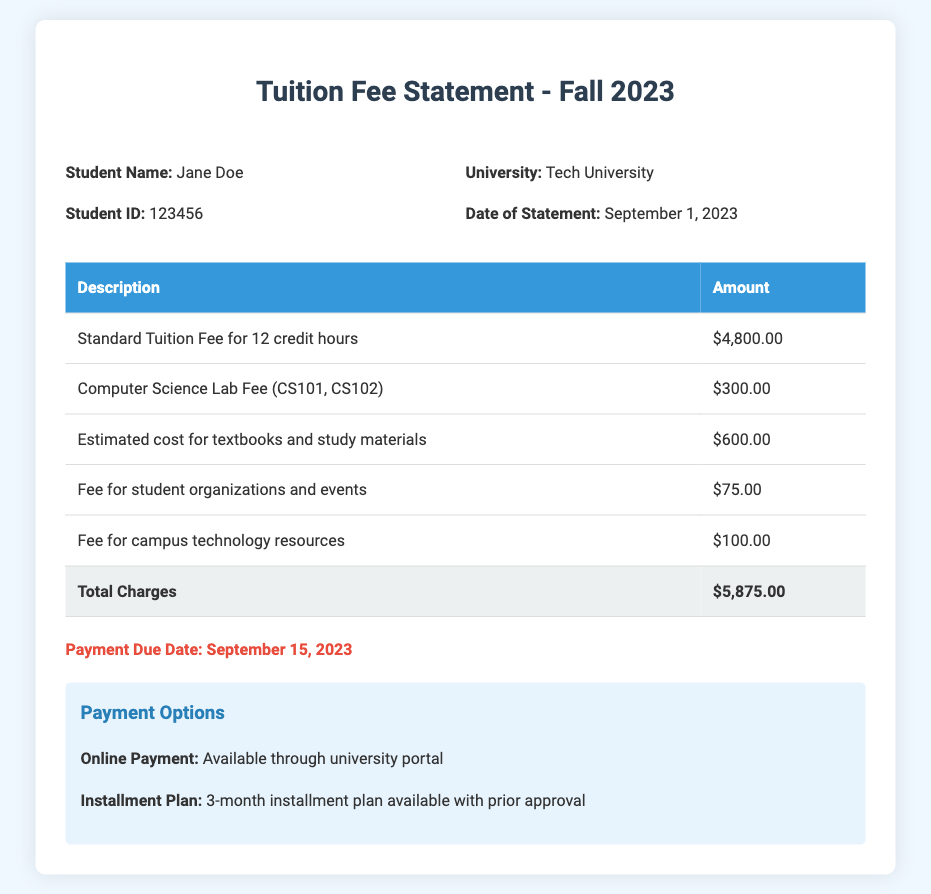What is the total amount of charges? The total amount of charges is explicitly listed in the document under "Total Charges."
Answer: $5,875.00 When is the payment due date? The payment due date is clearly stated in the document, specifically highlighted for visibility.
Answer: September 15, 2023 What is the fee for student organizations and events? The fee for student organizations and events is provided in the breakdown of charges.
Answer: $75.00 How much is the standard tuition fee for 12 credit hours? The document details the standard tuition fee for the specified credit hours.
Answer: $4,800.00 What university is listed on the tuition fee statement? The university is mentioned in the header section of the document.
Answer: Tech University What is the estimated cost for textbooks and study materials? The estimated cost for textbooks and study materials is listed in the additional expenses section.
Answer: $600.00 Is there an installment plan option available? The payment options section includes information about installment plans.
Answer: Yes Which courses incur a lab fee? The courses that include a lab fee are explicitly mentioned in the breakdown of charges.
Answer: CS101, CS102 What is included in the fee for campus technology resources? The document lists the fee for campus technology resources among other charges.
Answer: $100.00 